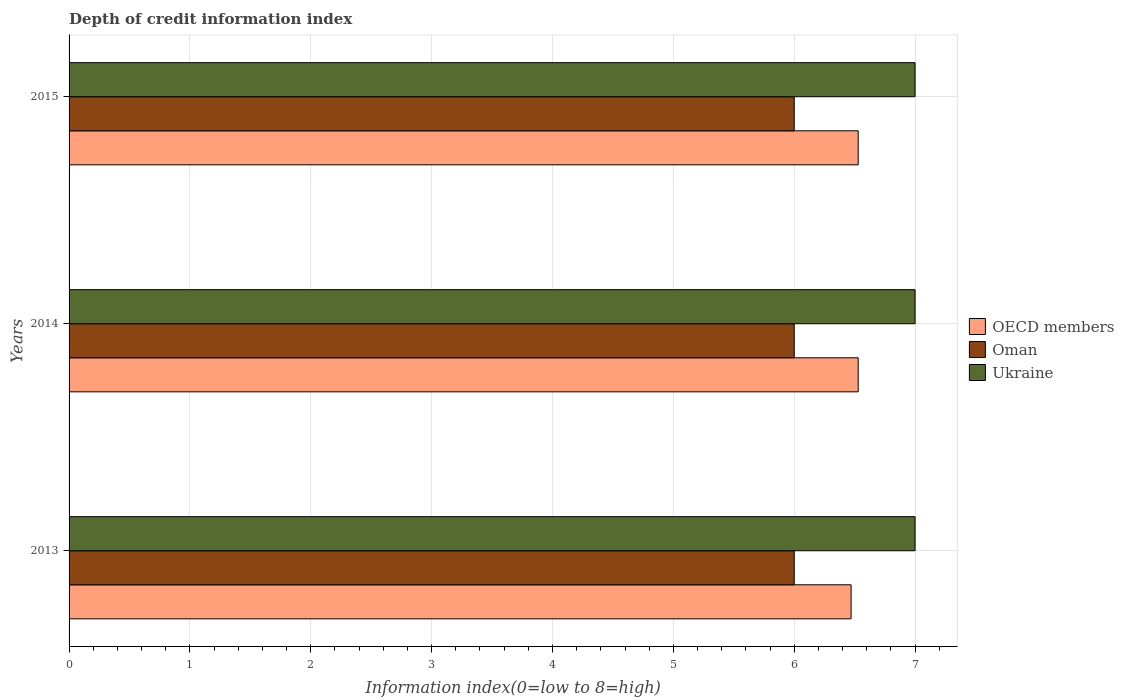How many different coloured bars are there?
Offer a terse response. 3. Are the number of bars per tick equal to the number of legend labels?
Your response must be concise. Yes. How many bars are there on the 3rd tick from the top?
Keep it short and to the point. 3. How many bars are there on the 1st tick from the bottom?
Offer a very short reply. 3. What is the label of the 3rd group of bars from the top?
Give a very brief answer. 2013. What is the information index in Ukraine in 2015?
Provide a succinct answer. 7. Across all years, what is the maximum information index in OECD members?
Offer a very short reply. 6.53. Across all years, what is the minimum information index in Oman?
Your response must be concise. 6. In which year was the information index in OECD members maximum?
Offer a very short reply. 2014. In which year was the information index in OECD members minimum?
Keep it short and to the point. 2013. What is the total information index in Ukraine in the graph?
Your answer should be compact. 21. What is the difference between the information index in OECD members in 2014 and the information index in Oman in 2013?
Give a very brief answer. 0.53. What is the average information index in OECD members per year?
Give a very brief answer. 6.51. In the year 2014, what is the difference between the information index in Ukraine and information index in Oman?
Provide a short and direct response. 1. In how many years, is the information index in OECD members greater than 2.2 ?
Offer a very short reply. 3. What is the ratio of the information index in OECD members in 2014 to that in 2015?
Provide a succinct answer. 1. Is the information index in Oman in 2013 less than that in 2015?
Give a very brief answer. No. Is the difference between the information index in Ukraine in 2013 and 2014 greater than the difference between the information index in Oman in 2013 and 2014?
Provide a short and direct response. No. What is the difference between the highest and the lowest information index in OECD members?
Offer a terse response. 0.06. Is the sum of the information index in OECD members in 2013 and 2014 greater than the maximum information index in Oman across all years?
Your response must be concise. Yes. What does the 2nd bar from the top in 2015 represents?
Offer a very short reply. Oman. What does the 3rd bar from the bottom in 2013 represents?
Provide a succinct answer. Ukraine. Is it the case that in every year, the sum of the information index in Oman and information index in Ukraine is greater than the information index in OECD members?
Offer a very short reply. Yes. How many bars are there?
Ensure brevity in your answer.  9. What is the difference between two consecutive major ticks on the X-axis?
Your answer should be compact. 1. Does the graph contain grids?
Make the answer very short. Yes. Where does the legend appear in the graph?
Offer a very short reply. Center right. What is the title of the graph?
Your answer should be very brief. Depth of credit information index. Does "Timor-Leste" appear as one of the legend labels in the graph?
Your answer should be very brief. No. What is the label or title of the X-axis?
Offer a very short reply. Information index(0=low to 8=high). What is the label or title of the Y-axis?
Provide a short and direct response. Years. What is the Information index(0=low to 8=high) of OECD members in 2013?
Your response must be concise. 6.47. What is the Information index(0=low to 8=high) in OECD members in 2014?
Offer a very short reply. 6.53. What is the Information index(0=low to 8=high) in Oman in 2014?
Your answer should be very brief. 6. What is the Information index(0=low to 8=high) of Ukraine in 2014?
Provide a succinct answer. 7. What is the Information index(0=low to 8=high) of OECD members in 2015?
Ensure brevity in your answer.  6.53. Across all years, what is the maximum Information index(0=low to 8=high) of OECD members?
Provide a short and direct response. 6.53. Across all years, what is the maximum Information index(0=low to 8=high) of Ukraine?
Your answer should be very brief. 7. Across all years, what is the minimum Information index(0=low to 8=high) of OECD members?
Ensure brevity in your answer.  6.47. What is the total Information index(0=low to 8=high) of OECD members in the graph?
Give a very brief answer. 19.53. What is the total Information index(0=low to 8=high) in Ukraine in the graph?
Provide a short and direct response. 21. What is the difference between the Information index(0=low to 8=high) of OECD members in 2013 and that in 2014?
Your response must be concise. -0.06. What is the difference between the Information index(0=low to 8=high) in Oman in 2013 and that in 2014?
Your answer should be very brief. 0. What is the difference between the Information index(0=low to 8=high) of Ukraine in 2013 and that in 2014?
Your response must be concise. 0. What is the difference between the Information index(0=low to 8=high) of OECD members in 2013 and that in 2015?
Offer a terse response. -0.06. What is the difference between the Information index(0=low to 8=high) of Oman in 2013 and that in 2015?
Offer a terse response. 0. What is the difference between the Information index(0=low to 8=high) in Ukraine in 2013 and that in 2015?
Provide a short and direct response. 0. What is the difference between the Information index(0=low to 8=high) in OECD members in 2014 and that in 2015?
Give a very brief answer. 0. What is the difference between the Information index(0=low to 8=high) in Oman in 2014 and that in 2015?
Your answer should be very brief. 0. What is the difference between the Information index(0=low to 8=high) of OECD members in 2013 and the Information index(0=low to 8=high) of Oman in 2014?
Provide a succinct answer. 0.47. What is the difference between the Information index(0=low to 8=high) in OECD members in 2013 and the Information index(0=low to 8=high) in Ukraine in 2014?
Keep it short and to the point. -0.53. What is the difference between the Information index(0=low to 8=high) of OECD members in 2013 and the Information index(0=low to 8=high) of Oman in 2015?
Ensure brevity in your answer.  0.47. What is the difference between the Information index(0=low to 8=high) in OECD members in 2013 and the Information index(0=low to 8=high) in Ukraine in 2015?
Provide a succinct answer. -0.53. What is the difference between the Information index(0=low to 8=high) of Oman in 2013 and the Information index(0=low to 8=high) of Ukraine in 2015?
Offer a terse response. -1. What is the difference between the Information index(0=low to 8=high) in OECD members in 2014 and the Information index(0=low to 8=high) in Oman in 2015?
Provide a short and direct response. 0.53. What is the difference between the Information index(0=low to 8=high) in OECD members in 2014 and the Information index(0=low to 8=high) in Ukraine in 2015?
Make the answer very short. -0.47. What is the average Information index(0=low to 8=high) of OECD members per year?
Keep it short and to the point. 6.51. What is the average Information index(0=low to 8=high) in Oman per year?
Your response must be concise. 6. In the year 2013, what is the difference between the Information index(0=low to 8=high) in OECD members and Information index(0=low to 8=high) in Oman?
Keep it short and to the point. 0.47. In the year 2013, what is the difference between the Information index(0=low to 8=high) of OECD members and Information index(0=low to 8=high) of Ukraine?
Offer a terse response. -0.53. In the year 2014, what is the difference between the Information index(0=low to 8=high) of OECD members and Information index(0=low to 8=high) of Oman?
Your answer should be compact. 0.53. In the year 2014, what is the difference between the Information index(0=low to 8=high) of OECD members and Information index(0=low to 8=high) of Ukraine?
Your response must be concise. -0.47. In the year 2014, what is the difference between the Information index(0=low to 8=high) of Oman and Information index(0=low to 8=high) of Ukraine?
Your answer should be compact. -1. In the year 2015, what is the difference between the Information index(0=low to 8=high) in OECD members and Information index(0=low to 8=high) in Oman?
Provide a succinct answer. 0.53. In the year 2015, what is the difference between the Information index(0=low to 8=high) of OECD members and Information index(0=low to 8=high) of Ukraine?
Provide a succinct answer. -0.47. What is the ratio of the Information index(0=low to 8=high) in OECD members in 2013 to that in 2014?
Your answer should be very brief. 0.99. What is the ratio of the Information index(0=low to 8=high) in Oman in 2013 to that in 2014?
Ensure brevity in your answer.  1. What is the ratio of the Information index(0=low to 8=high) of Oman in 2013 to that in 2015?
Your answer should be very brief. 1. What is the ratio of the Information index(0=low to 8=high) in Ukraine in 2013 to that in 2015?
Your response must be concise. 1. What is the ratio of the Information index(0=low to 8=high) of OECD members in 2014 to that in 2015?
Provide a succinct answer. 1. What is the ratio of the Information index(0=low to 8=high) of Oman in 2014 to that in 2015?
Make the answer very short. 1. What is the difference between the highest and the second highest Information index(0=low to 8=high) in OECD members?
Offer a terse response. 0. What is the difference between the highest and the second highest Information index(0=low to 8=high) of Oman?
Make the answer very short. 0. What is the difference between the highest and the second highest Information index(0=low to 8=high) of Ukraine?
Your answer should be very brief. 0. What is the difference between the highest and the lowest Information index(0=low to 8=high) of OECD members?
Your response must be concise. 0.06. What is the difference between the highest and the lowest Information index(0=low to 8=high) in Oman?
Your answer should be very brief. 0. What is the difference between the highest and the lowest Information index(0=low to 8=high) of Ukraine?
Your answer should be very brief. 0. 